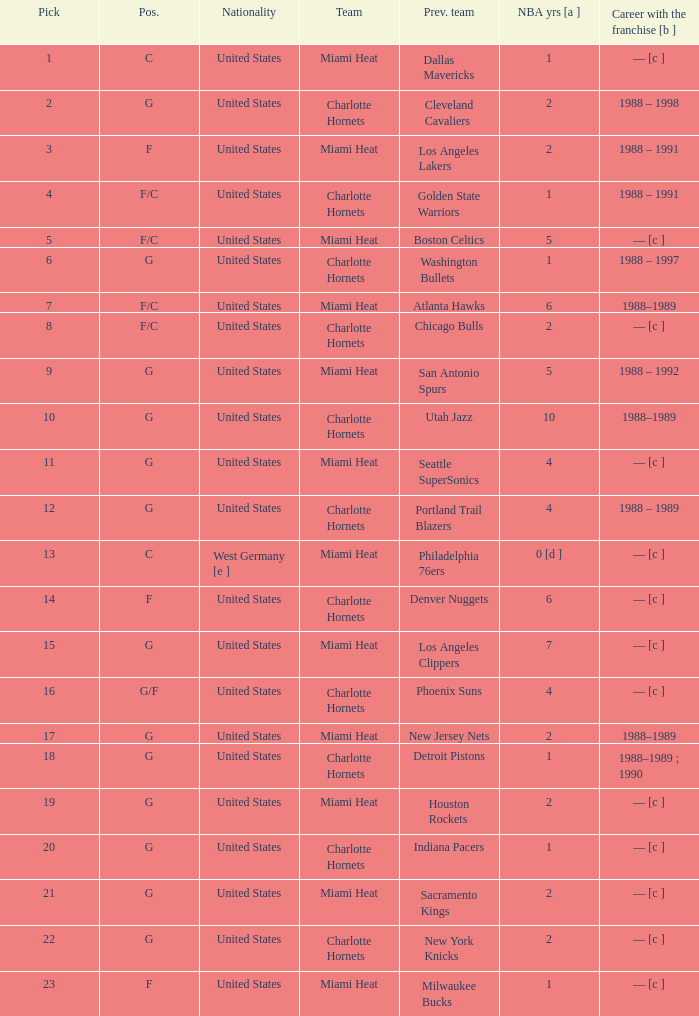What is the previous team of the player with 4 NBA years and a pick less than 16? Seattle SuperSonics, Portland Trail Blazers. 